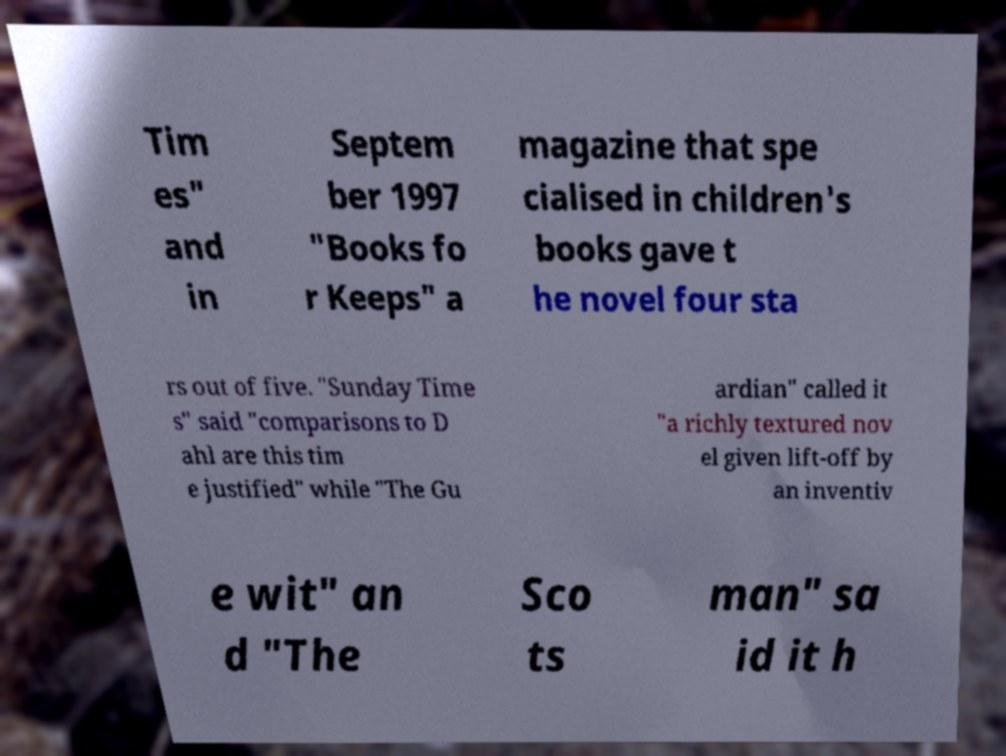Can you read and provide the text displayed in the image?This photo seems to have some interesting text. Can you extract and type it out for me? Tim es" and in Septem ber 1997 "Books fo r Keeps" a magazine that spe cialised in children's books gave t he novel four sta rs out of five. "Sunday Time s" said "comparisons to D ahl are this tim e justified" while "The Gu ardian" called it "a richly textured nov el given lift-off by an inventiv e wit" an d "The Sco ts man" sa id it h 